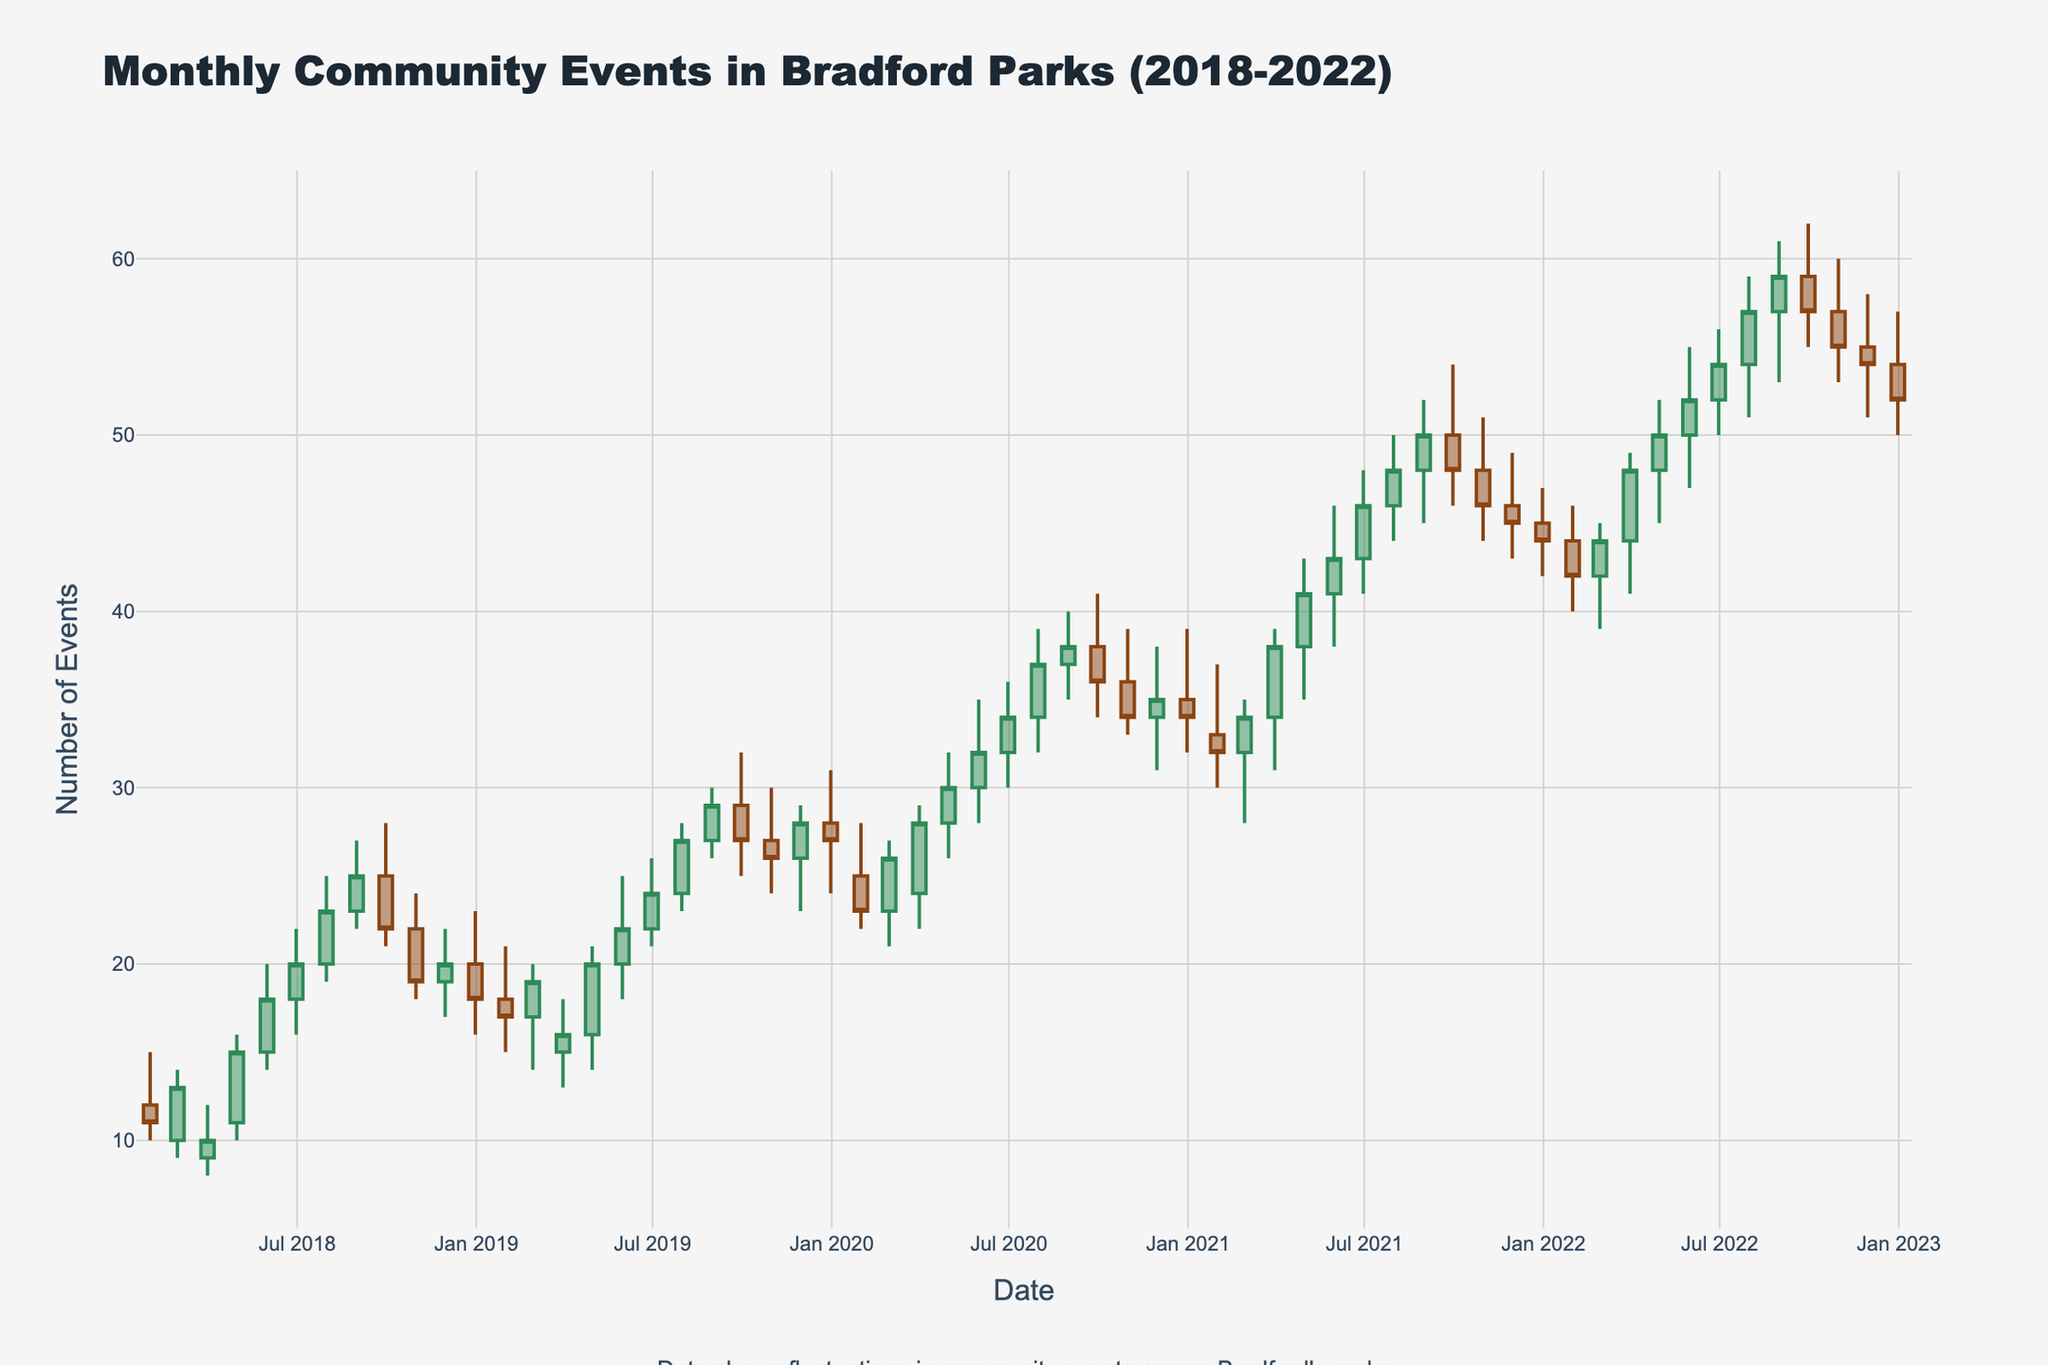What is the title of the figure? The title is usually located at the top of the figure. In this case, it states "Monthly Community Events in Bradford Parks (2018-2022)".
Answer: Monthly Community Events in Bradford Parks (2018-2022) How many months of data are shown in the figure? Each candlestick represents one month, and there are multiple candlesticks across the 5-year period. By counting the number of candlesticks, we find there are 60 months of data.
Answer: 60 Which month and year had the highest recorded event count? The highest event count can be identified by the highest point in all the candles. Checking the 2020-07 data, the 'High' value is 39 which is the highest in the given period.
Answer: July 2020 What is the color of candlesticks indicating an increase in events? The figure uses different colors for increasing and decreasing values. Sea Green indicates an increase in events as per the explanation.
Answer: Sea Green Which park had the most fluctuation in events in 2021? To answer this, we need to look at the difference between the 'High' and 'Low' values for each candlestick in 2021. Harold Park in July 2021 has the highest fluctuation (50-44 = 6).
Answer: Harold Park Which month had the lowest closing number of events in 2019? The closing values at the end of each month indicate the month's end event count. In 2019, the lowest closing value is January with a 'Close' value of 17.
Answer: January 2019 How did the number of events change from December 2020 to January 2021? By comparing the 'Close' value of December 2020 and January 2021, we see it decreased from 34 to 32, which is a reduction of 2 events.
Answer: Decreased by 2 What was the event trend in Harold Park from 2018 to 2022? Observing the candlesticks specifically associated with Harold Park over the years shows an upward trend in the number of events.
Answer: Upward trend Between which two consecutive months in 2022 was the difference in the number of events the largest? By looking at the difference in 'Close' values between consecutive months, from February to March the 'Close' value increases from 44 to 48 – a difference of 4 events.
Answer: February to March Which year had the maximum overall number of events? Summing the 'Close' values at the end of each year helps determine the overall annual events. 2021 had the highest cumulative value when adding up each month's 'Close' value.
Answer: 2021 